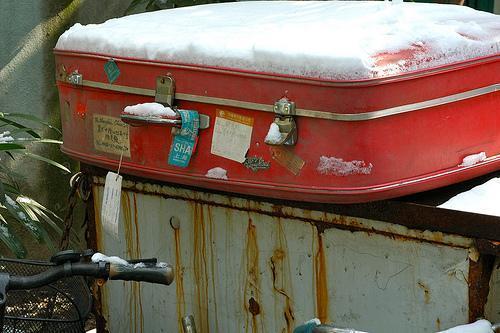How many suitcases are there?
Give a very brief answer. 1. 